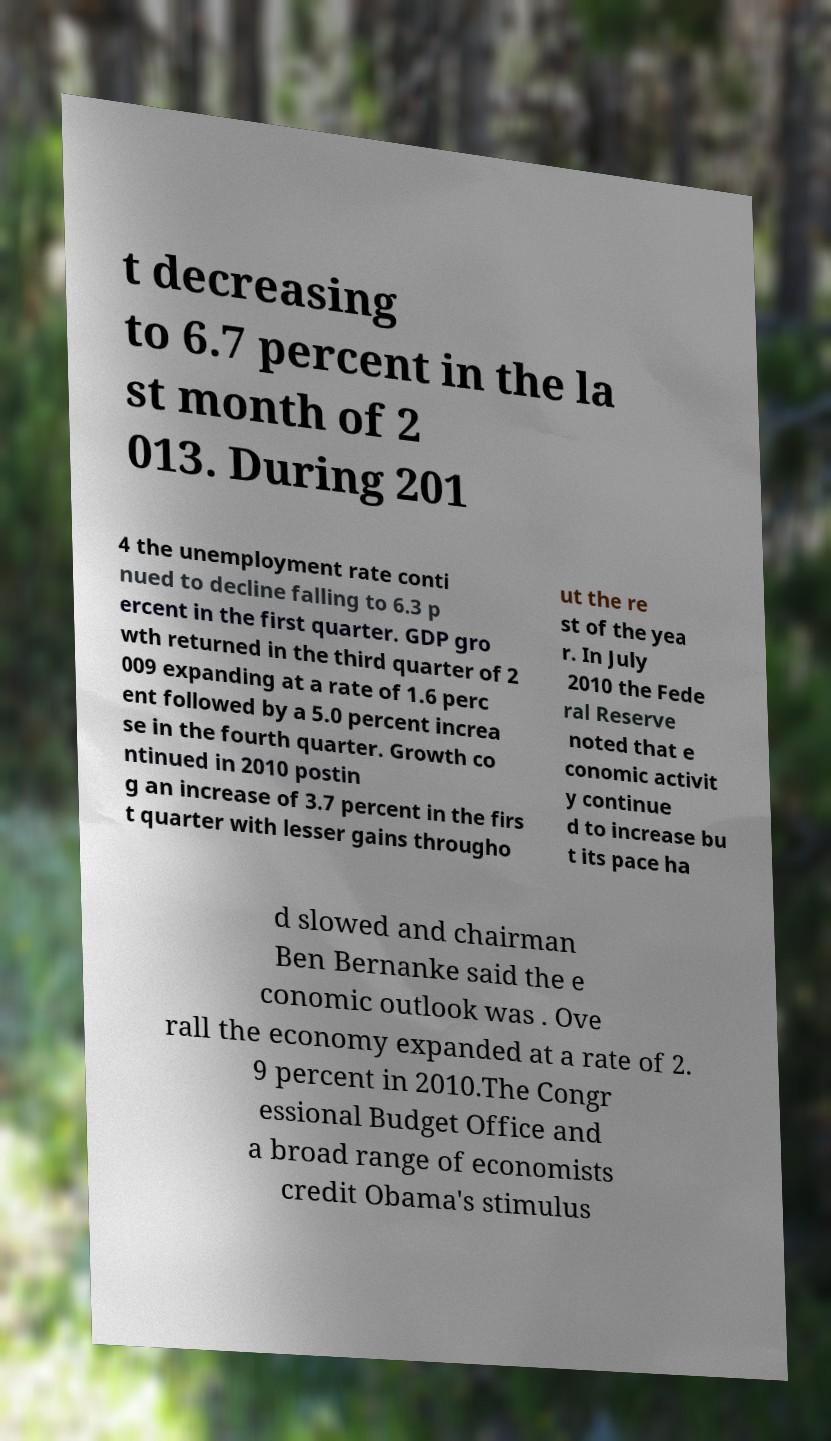Please read and relay the text visible in this image. What does it say? t decreasing to 6.7 percent in the la st month of 2 013. During 201 4 the unemployment rate conti nued to decline falling to 6.3 p ercent in the first quarter. GDP gro wth returned in the third quarter of 2 009 expanding at a rate of 1.6 perc ent followed by a 5.0 percent increa se in the fourth quarter. Growth co ntinued in 2010 postin g an increase of 3.7 percent in the firs t quarter with lesser gains througho ut the re st of the yea r. In July 2010 the Fede ral Reserve noted that e conomic activit y continue d to increase bu t its pace ha d slowed and chairman Ben Bernanke said the e conomic outlook was . Ove rall the economy expanded at a rate of 2. 9 percent in 2010.The Congr essional Budget Office and a broad range of economists credit Obama's stimulus 